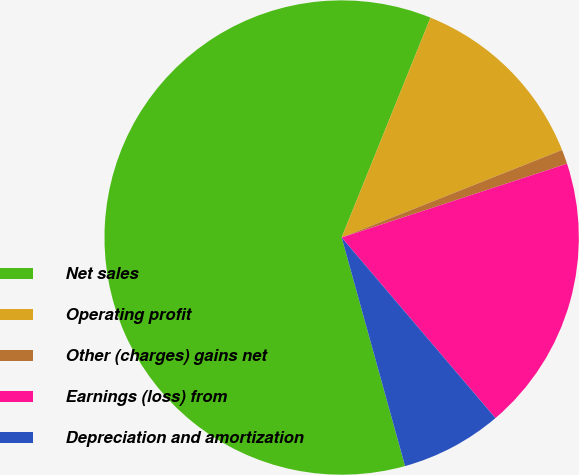Convert chart. <chart><loc_0><loc_0><loc_500><loc_500><pie_chart><fcel>Net sales<fcel>Operating profit<fcel>Other (charges) gains net<fcel>Earnings (loss) from<fcel>Depreciation and amortization<nl><fcel>60.42%<fcel>12.87%<fcel>0.98%<fcel>18.81%<fcel>6.92%<nl></chart> 